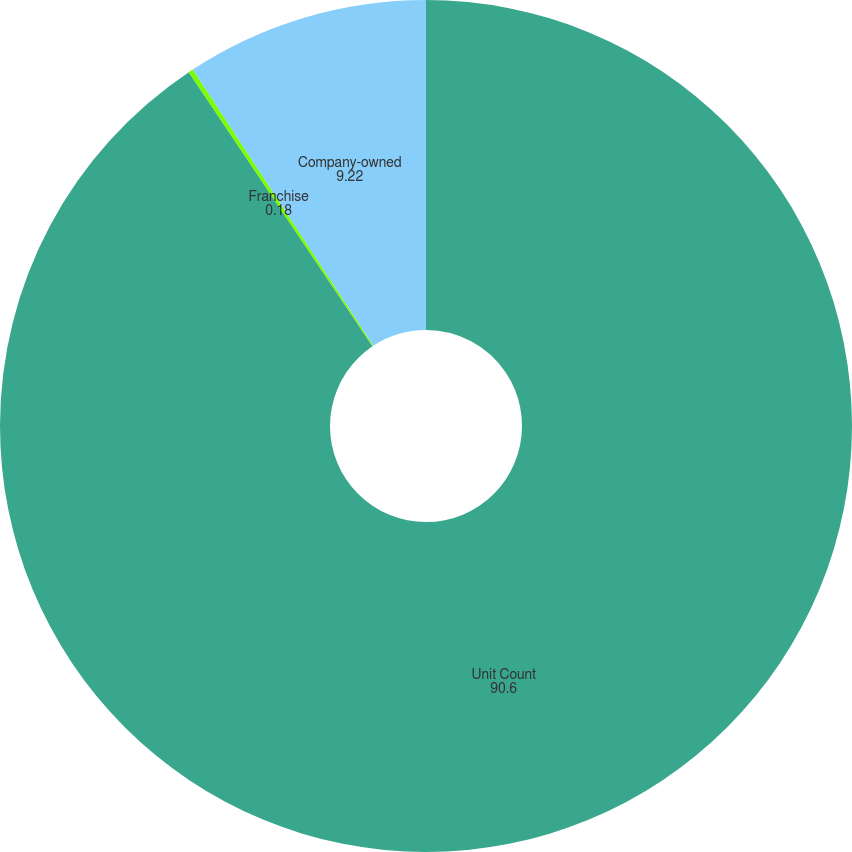<chart> <loc_0><loc_0><loc_500><loc_500><pie_chart><fcel>Unit Count<fcel>Franchise<fcel>Company-owned<nl><fcel>90.6%<fcel>0.18%<fcel>9.22%<nl></chart> 